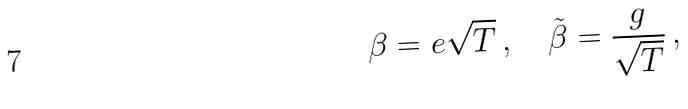Convert formula to latex. <formula><loc_0><loc_0><loc_500><loc_500>\beta = e \sqrt { T } \, , \quad \tilde { \beta } = \frac { g } { \sqrt { T } } \, ,</formula> 